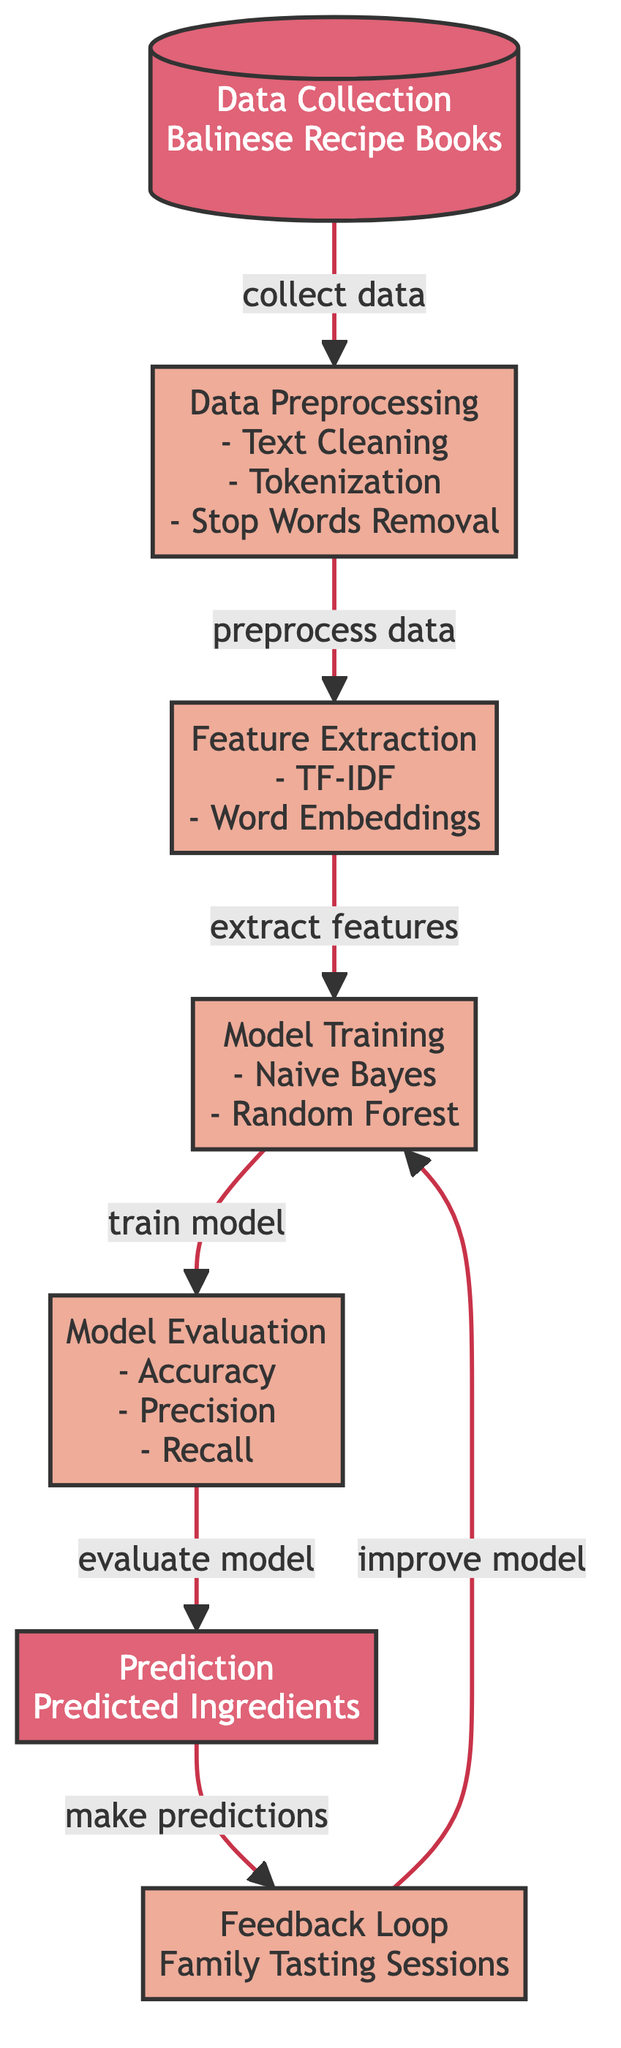What is the first step in the process? The first step in the process is "Data Collection" from "Balinese Recipe Books", as indicated in the diagram. This node is the starting point that collects the necessary data before any processing.
Answer: Data Collection How many processes are involved in this diagram? There are five processes involved in the diagram, which are data preprocessing, feature extraction, model training, model evaluation, and feedback loop. These processes are represented by nodes labeled as processes in the flowchart.
Answer: Five Which model is trained after feature extraction? After feature extraction, the model that is trained is "Naive Bayes" and "Random Forest," as shown in the model training node. This node indicates the methods used for training the predictive model.
Answer: Naive Bayes and Random Forest What happens after model evaluation? After model evaluation, the next step is "Prediction," specifically producing predicted ingredients. This transition indicates that the evaluation leads to generating outputs based on the trained model.
Answer: Prediction How does feedback help in the diagram? Feedback helps improve the model as it leads back to the model training node. This loop indicates that insights gained from family tasting sessions are utilized to enhance the predictive process.
Answer: Improve model What techniques are used for feature extraction? The techniques used for feature extraction are "TF-IDF" and "Word Embeddings," specified in the corresponding process node in the diagram. These techniques are utilized to convert text data into features for modeling.
Answer: TF-IDF and Word Embeddings What is the last step in the flow of the diagram? The last step in the flow of the diagram is "Predicted Ingredients," which indicates the final output of the entire process following evaluation and prediction. This step represents the end result of the model's predictions.
Answer: Predicted Ingredients Which step occurs before data preprocessing? The step that occurs before data preprocessing is "Data Collection," which involves gathering data that is necessary for all subsequent processing steps. It is the foundational step in the diagram's flow.
Answer: Data Collection What does the feedback loop involve? The feedback loop involves "Family Tasting Sessions," where the recipe results are evaluated, and insights are gathered, which are then used to enhance the model training process.
Answer: Family Tasting Sessions 